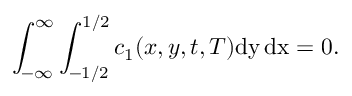Convert formula to latex. <formula><loc_0><loc_0><loc_500><loc_500>\int _ { - \infty } ^ { \infty } \int _ { - 1 / 2 } ^ { 1 / 2 } c _ { 1 } ( x , y , t , T ) d y \, d x = 0 .</formula> 